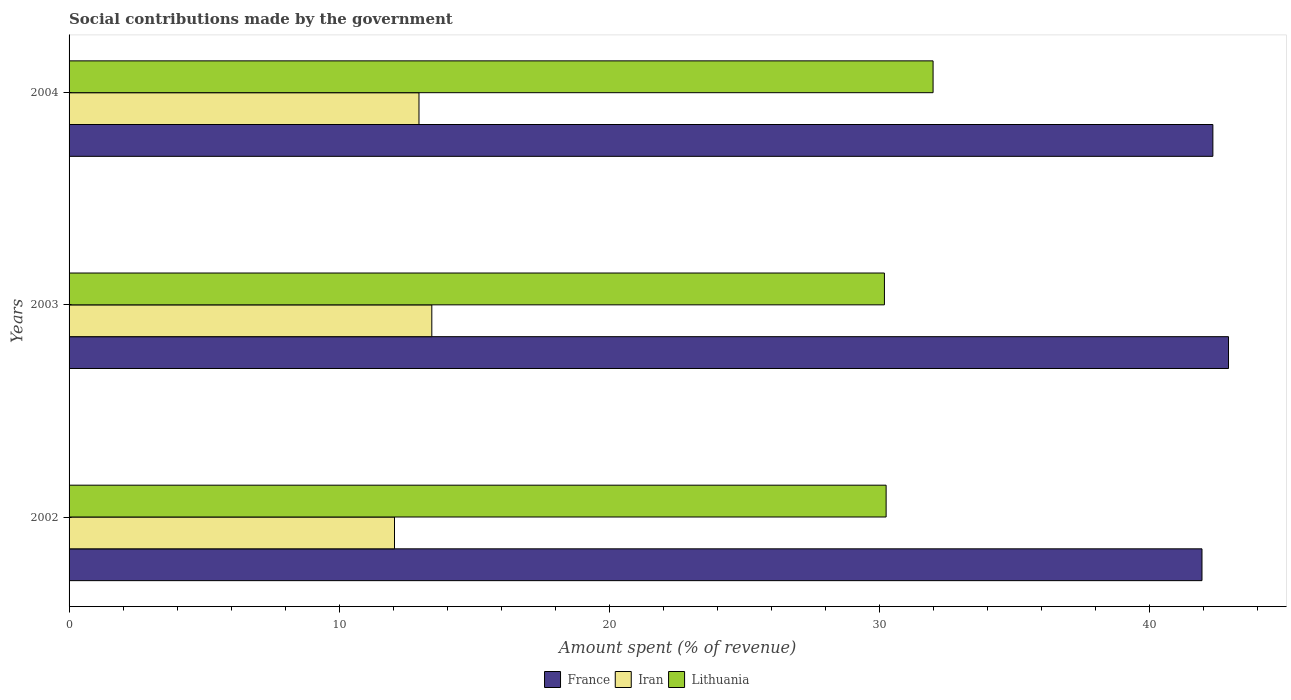Are the number of bars per tick equal to the number of legend labels?
Ensure brevity in your answer.  Yes. Are the number of bars on each tick of the Y-axis equal?
Give a very brief answer. Yes. What is the label of the 3rd group of bars from the top?
Make the answer very short. 2002. In how many cases, is the number of bars for a given year not equal to the number of legend labels?
Offer a terse response. 0. What is the amount spent (in %) on social contributions in Lithuania in 2004?
Give a very brief answer. 31.99. Across all years, what is the maximum amount spent (in %) on social contributions in France?
Your answer should be compact. 42.93. Across all years, what is the minimum amount spent (in %) on social contributions in Iran?
Your answer should be very brief. 12.05. What is the total amount spent (in %) on social contributions in Lithuania in the graph?
Your response must be concise. 92.44. What is the difference between the amount spent (in %) on social contributions in France in 2003 and that in 2004?
Ensure brevity in your answer.  0.58. What is the difference between the amount spent (in %) on social contributions in Iran in 2004 and the amount spent (in %) on social contributions in Lithuania in 2003?
Provide a short and direct response. -17.23. What is the average amount spent (in %) on social contributions in Lithuania per year?
Provide a succinct answer. 30.81. In the year 2004, what is the difference between the amount spent (in %) on social contributions in France and amount spent (in %) on social contributions in Iran?
Provide a succinct answer. 29.4. In how many years, is the amount spent (in %) on social contributions in France greater than 14 %?
Your response must be concise. 3. What is the ratio of the amount spent (in %) on social contributions in France in 2003 to that in 2004?
Offer a very short reply. 1.01. Is the amount spent (in %) on social contributions in France in 2002 less than that in 2003?
Your response must be concise. Yes. Is the difference between the amount spent (in %) on social contributions in France in 2002 and 2003 greater than the difference between the amount spent (in %) on social contributions in Iran in 2002 and 2003?
Your answer should be compact. Yes. What is the difference between the highest and the second highest amount spent (in %) on social contributions in Iran?
Your response must be concise. 0.47. What is the difference between the highest and the lowest amount spent (in %) on social contributions in Iran?
Ensure brevity in your answer.  1.38. Is the sum of the amount spent (in %) on social contributions in Lithuania in 2002 and 2004 greater than the maximum amount spent (in %) on social contributions in Iran across all years?
Give a very brief answer. Yes. What does the 1st bar from the top in 2004 represents?
Your response must be concise. Lithuania. What does the 3rd bar from the bottom in 2003 represents?
Your answer should be compact. Lithuania. Does the graph contain any zero values?
Your response must be concise. No. Does the graph contain grids?
Give a very brief answer. No. Where does the legend appear in the graph?
Ensure brevity in your answer.  Bottom center. What is the title of the graph?
Ensure brevity in your answer.  Social contributions made by the government. Does "Tanzania" appear as one of the legend labels in the graph?
Your response must be concise. No. What is the label or title of the X-axis?
Offer a very short reply. Amount spent (% of revenue). What is the Amount spent (% of revenue) in France in 2002?
Provide a short and direct response. 41.95. What is the Amount spent (% of revenue) of Iran in 2002?
Offer a terse response. 12.05. What is the Amount spent (% of revenue) in Lithuania in 2002?
Your answer should be compact. 30.25. What is the Amount spent (% of revenue) of France in 2003?
Offer a very short reply. 42.93. What is the Amount spent (% of revenue) in Iran in 2003?
Offer a terse response. 13.43. What is the Amount spent (% of revenue) in Lithuania in 2003?
Your response must be concise. 30.19. What is the Amount spent (% of revenue) in France in 2004?
Keep it short and to the point. 42.35. What is the Amount spent (% of revenue) in Iran in 2004?
Keep it short and to the point. 12.96. What is the Amount spent (% of revenue) in Lithuania in 2004?
Offer a very short reply. 31.99. Across all years, what is the maximum Amount spent (% of revenue) of France?
Your answer should be very brief. 42.93. Across all years, what is the maximum Amount spent (% of revenue) in Iran?
Offer a terse response. 13.43. Across all years, what is the maximum Amount spent (% of revenue) of Lithuania?
Your response must be concise. 31.99. Across all years, what is the minimum Amount spent (% of revenue) in France?
Offer a terse response. 41.95. Across all years, what is the minimum Amount spent (% of revenue) in Iran?
Offer a very short reply. 12.05. Across all years, what is the minimum Amount spent (% of revenue) of Lithuania?
Offer a very short reply. 30.19. What is the total Amount spent (% of revenue) in France in the graph?
Your response must be concise. 127.23. What is the total Amount spent (% of revenue) of Iran in the graph?
Offer a very short reply. 38.44. What is the total Amount spent (% of revenue) in Lithuania in the graph?
Offer a very short reply. 92.44. What is the difference between the Amount spent (% of revenue) of France in 2002 and that in 2003?
Your answer should be very brief. -0.98. What is the difference between the Amount spent (% of revenue) in Iran in 2002 and that in 2003?
Make the answer very short. -1.38. What is the difference between the Amount spent (% of revenue) in Lithuania in 2002 and that in 2003?
Make the answer very short. 0.06. What is the difference between the Amount spent (% of revenue) in France in 2002 and that in 2004?
Provide a succinct answer. -0.4. What is the difference between the Amount spent (% of revenue) in Iran in 2002 and that in 2004?
Your answer should be very brief. -0.91. What is the difference between the Amount spent (% of revenue) of Lithuania in 2002 and that in 2004?
Provide a succinct answer. -1.74. What is the difference between the Amount spent (% of revenue) in France in 2003 and that in 2004?
Make the answer very short. 0.58. What is the difference between the Amount spent (% of revenue) in Iran in 2003 and that in 2004?
Keep it short and to the point. 0.47. What is the difference between the Amount spent (% of revenue) in Lithuania in 2003 and that in 2004?
Offer a very short reply. -1.8. What is the difference between the Amount spent (% of revenue) in France in 2002 and the Amount spent (% of revenue) in Iran in 2003?
Give a very brief answer. 28.52. What is the difference between the Amount spent (% of revenue) in France in 2002 and the Amount spent (% of revenue) in Lithuania in 2003?
Give a very brief answer. 11.76. What is the difference between the Amount spent (% of revenue) in Iran in 2002 and the Amount spent (% of revenue) in Lithuania in 2003?
Provide a succinct answer. -18.14. What is the difference between the Amount spent (% of revenue) of France in 2002 and the Amount spent (% of revenue) of Iran in 2004?
Provide a short and direct response. 28.99. What is the difference between the Amount spent (% of revenue) of France in 2002 and the Amount spent (% of revenue) of Lithuania in 2004?
Offer a terse response. 9.96. What is the difference between the Amount spent (% of revenue) in Iran in 2002 and the Amount spent (% of revenue) in Lithuania in 2004?
Offer a terse response. -19.94. What is the difference between the Amount spent (% of revenue) in France in 2003 and the Amount spent (% of revenue) in Iran in 2004?
Offer a very short reply. 29.97. What is the difference between the Amount spent (% of revenue) in France in 2003 and the Amount spent (% of revenue) in Lithuania in 2004?
Offer a terse response. 10.94. What is the difference between the Amount spent (% of revenue) in Iran in 2003 and the Amount spent (% of revenue) in Lithuania in 2004?
Provide a short and direct response. -18.56. What is the average Amount spent (% of revenue) in France per year?
Your response must be concise. 42.41. What is the average Amount spent (% of revenue) of Iran per year?
Your answer should be very brief. 12.81. What is the average Amount spent (% of revenue) of Lithuania per year?
Ensure brevity in your answer.  30.81. In the year 2002, what is the difference between the Amount spent (% of revenue) in France and Amount spent (% of revenue) in Iran?
Provide a short and direct response. 29.9. In the year 2002, what is the difference between the Amount spent (% of revenue) of France and Amount spent (% of revenue) of Lithuania?
Keep it short and to the point. 11.7. In the year 2002, what is the difference between the Amount spent (% of revenue) of Iran and Amount spent (% of revenue) of Lithuania?
Ensure brevity in your answer.  -18.2. In the year 2003, what is the difference between the Amount spent (% of revenue) in France and Amount spent (% of revenue) in Iran?
Your answer should be compact. 29.5. In the year 2003, what is the difference between the Amount spent (% of revenue) of France and Amount spent (% of revenue) of Lithuania?
Provide a short and direct response. 12.74. In the year 2003, what is the difference between the Amount spent (% of revenue) of Iran and Amount spent (% of revenue) of Lithuania?
Give a very brief answer. -16.76. In the year 2004, what is the difference between the Amount spent (% of revenue) in France and Amount spent (% of revenue) in Iran?
Provide a succinct answer. 29.4. In the year 2004, what is the difference between the Amount spent (% of revenue) in France and Amount spent (% of revenue) in Lithuania?
Ensure brevity in your answer.  10.36. In the year 2004, what is the difference between the Amount spent (% of revenue) in Iran and Amount spent (% of revenue) in Lithuania?
Ensure brevity in your answer.  -19.04. What is the ratio of the Amount spent (% of revenue) in France in 2002 to that in 2003?
Provide a succinct answer. 0.98. What is the ratio of the Amount spent (% of revenue) in Iran in 2002 to that in 2003?
Ensure brevity in your answer.  0.9. What is the ratio of the Amount spent (% of revenue) in Lithuania in 2002 to that in 2003?
Your answer should be very brief. 1. What is the ratio of the Amount spent (% of revenue) of Iran in 2002 to that in 2004?
Provide a short and direct response. 0.93. What is the ratio of the Amount spent (% of revenue) in Lithuania in 2002 to that in 2004?
Your response must be concise. 0.95. What is the ratio of the Amount spent (% of revenue) of France in 2003 to that in 2004?
Your answer should be very brief. 1.01. What is the ratio of the Amount spent (% of revenue) of Iran in 2003 to that in 2004?
Your response must be concise. 1.04. What is the ratio of the Amount spent (% of revenue) in Lithuania in 2003 to that in 2004?
Your answer should be very brief. 0.94. What is the difference between the highest and the second highest Amount spent (% of revenue) in France?
Your answer should be very brief. 0.58. What is the difference between the highest and the second highest Amount spent (% of revenue) in Iran?
Offer a very short reply. 0.47. What is the difference between the highest and the second highest Amount spent (% of revenue) in Lithuania?
Your answer should be very brief. 1.74. What is the difference between the highest and the lowest Amount spent (% of revenue) of France?
Provide a short and direct response. 0.98. What is the difference between the highest and the lowest Amount spent (% of revenue) in Iran?
Provide a succinct answer. 1.38. What is the difference between the highest and the lowest Amount spent (% of revenue) of Lithuania?
Keep it short and to the point. 1.8. 